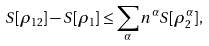Convert formula to latex. <formula><loc_0><loc_0><loc_500><loc_500>S [ \rho _ { 1 2 } ] - S [ \rho _ { 1 } ] \leq \sum _ { \alpha } n ^ { \alpha } S [ \rho _ { 2 } ^ { \alpha } ] ,</formula> 